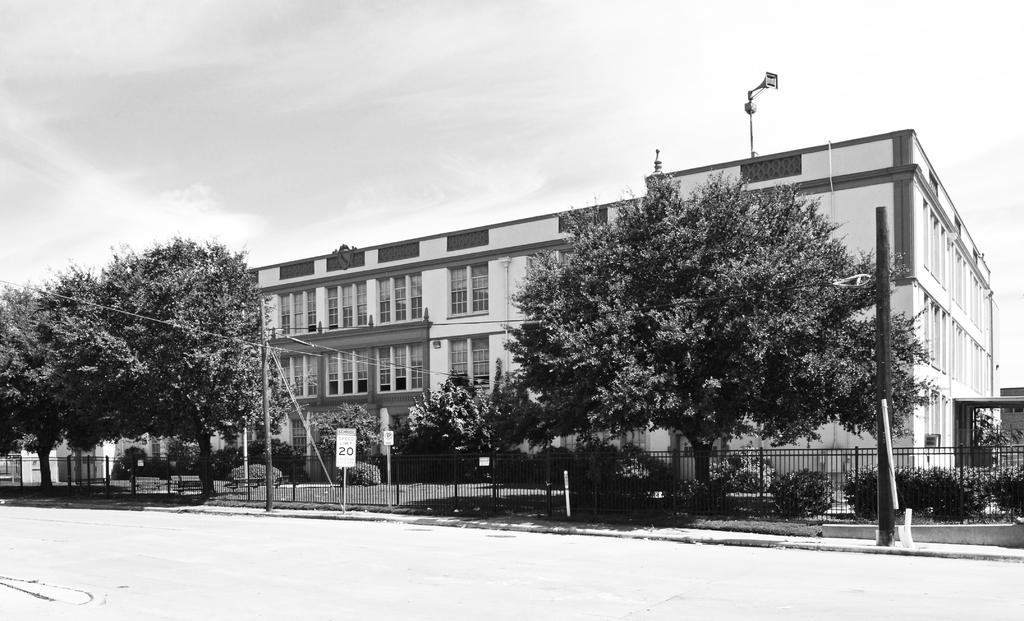What type of structure is visible in the image? There is a building in the image. What is located in front of the building? There is a group of trees, plants, grass, fencing, and poles with boards in front of the building. What can be seen at the top of the image? The sky is visible at the top of the image. What advice is being given by the bell in the image? There is no bell present in the image, so no advice can be given. 